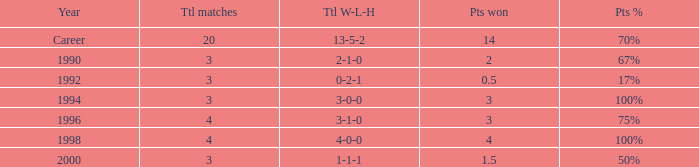Can you tell me the lowest Points won that has the Total matches of 4, and the Total W-L-H of 4-0-0? 4.0. 